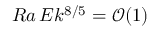<formula> <loc_0><loc_0><loc_500><loc_500>R a \, E k ^ { 8 / 5 } = \mathcal { O } ( 1 )</formula> 